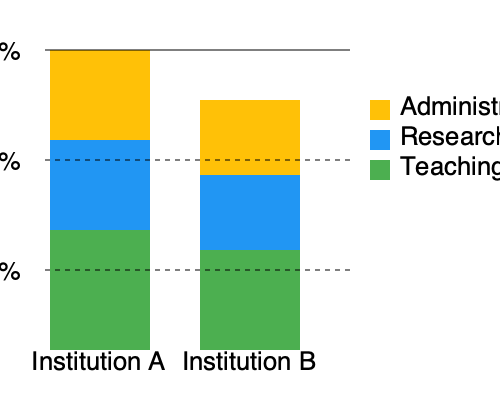Based on the stacked bar chart comparing budget allocations between Institution A and Institution B, which institution appears to prioritize research more heavily? How could this information be used to challenge the proposed tie-up? To answer this question, we need to analyze the budget allocation percentages for research in both institutions:

1. Identify the research allocation (blue section) for each institution:
   - Institution A: The blue section covers approximately 30% of the total bar.
   - Institution B: The blue section covers approximately 30% of the total bar.

2. Compare the research allocations:
   - Both institutions seem to allocate similar percentages to research.
   - However, Institution B's total budget appears larger (taller bar), which means more absolute funding for research.

3. Analyze other allocations:
   - Institution A allocates more to administration (yellow) proportionally.
   - Institution B allocates more to teaching (green) proportionally.

4. Consider how to use this information to challenge the tie-up:
   - Highlight that Institution B has a larger overall budget, potentially overshadowing Institution A.
   - Emphasize that Institution A spends more on administration, which could be seen as inefficient.
   - Point out that Institution B prioritizes teaching more, which could lead to a shift in focus away from Institution A's strengths.

5. Formulate an argument:
   The proposed tie-up could result in Institution A losing its unique identity and potentially facing budget cuts or reallocation, especially in administration, to align with Institution B's more teaching-focused approach.
Answer: Institution B prioritizes research more in absolute terms. This tie-up could lead to budget reallocation, potentially harming Institution A's administrative structure and unique identity. 